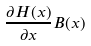Convert formula to latex. <formula><loc_0><loc_0><loc_500><loc_500>\frac { \partial H ( x ) } { \partial x } B ( x )</formula> 